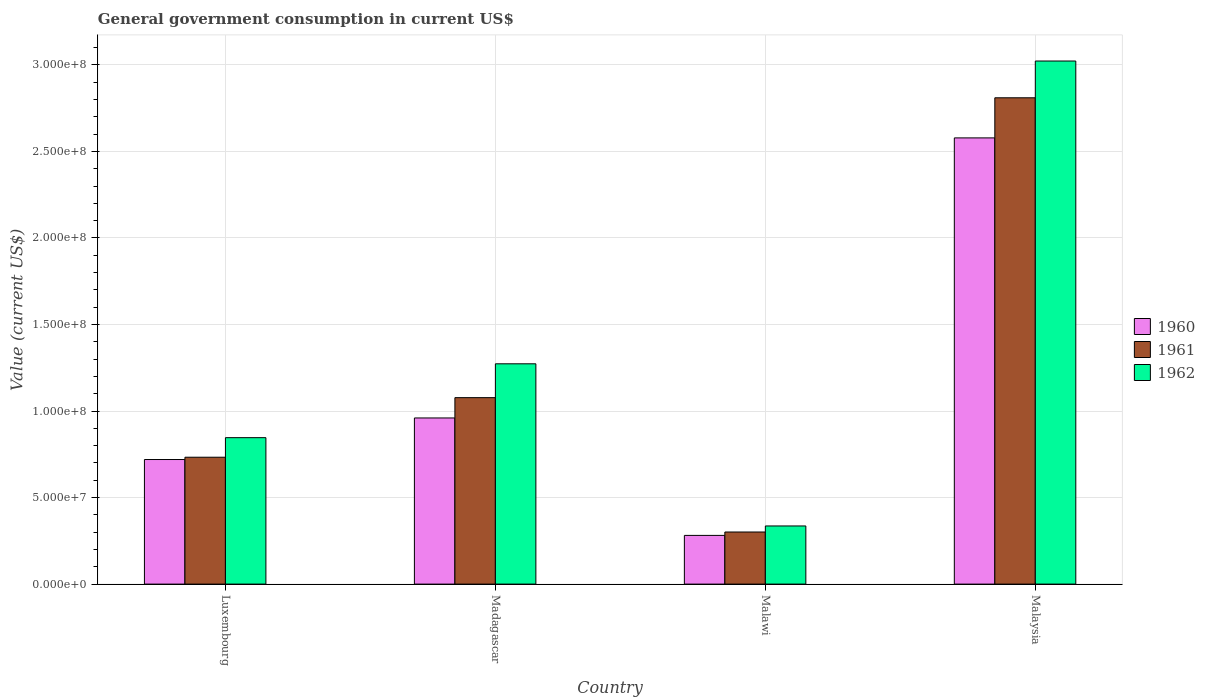Are the number of bars per tick equal to the number of legend labels?
Offer a very short reply. Yes. How many bars are there on the 3rd tick from the left?
Ensure brevity in your answer.  3. What is the label of the 4th group of bars from the left?
Your response must be concise. Malaysia. What is the government conusmption in 1960 in Malawi?
Make the answer very short. 2.81e+07. Across all countries, what is the maximum government conusmption in 1962?
Your response must be concise. 3.02e+08. Across all countries, what is the minimum government conusmption in 1960?
Provide a short and direct response. 2.81e+07. In which country was the government conusmption in 1962 maximum?
Your answer should be very brief. Malaysia. In which country was the government conusmption in 1962 minimum?
Provide a short and direct response. Malawi. What is the total government conusmption in 1962 in the graph?
Keep it short and to the point. 5.48e+08. What is the difference between the government conusmption in 1961 in Madagascar and that in Malawi?
Offer a very short reply. 7.76e+07. What is the difference between the government conusmption in 1960 in Malawi and the government conusmption in 1962 in Malaysia?
Offer a very short reply. -2.74e+08. What is the average government conusmption in 1962 per country?
Give a very brief answer. 1.37e+08. What is the difference between the government conusmption of/in 1961 and government conusmption of/in 1960 in Malaysia?
Keep it short and to the point. 2.32e+07. In how many countries, is the government conusmption in 1961 greater than 300000000 US$?
Offer a very short reply. 0. What is the ratio of the government conusmption in 1962 in Madagascar to that in Malaysia?
Provide a succinct answer. 0.42. Is the government conusmption in 1961 in Luxembourg less than that in Malawi?
Your response must be concise. No. Is the difference between the government conusmption in 1961 in Madagascar and Malaysia greater than the difference between the government conusmption in 1960 in Madagascar and Malaysia?
Give a very brief answer. No. What is the difference between the highest and the second highest government conusmption in 1962?
Provide a succinct answer. -4.27e+07. What is the difference between the highest and the lowest government conusmption in 1962?
Provide a succinct answer. 2.69e+08. Is the sum of the government conusmption in 1962 in Malawi and Malaysia greater than the maximum government conusmption in 1961 across all countries?
Provide a succinct answer. Yes. What does the 2nd bar from the right in Malawi represents?
Give a very brief answer. 1961. Are all the bars in the graph horizontal?
Your answer should be compact. No. What is the difference between two consecutive major ticks on the Y-axis?
Your response must be concise. 5.00e+07. Does the graph contain any zero values?
Your answer should be very brief. No. Does the graph contain grids?
Offer a very short reply. Yes. How many legend labels are there?
Offer a very short reply. 3. What is the title of the graph?
Ensure brevity in your answer.  General government consumption in current US$. What is the label or title of the X-axis?
Make the answer very short. Country. What is the label or title of the Y-axis?
Provide a short and direct response. Value (current US$). What is the Value (current US$) of 1960 in Luxembourg?
Provide a short and direct response. 7.20e+07. What is the Value (current US$) in 1961 in Luxembourg?
Give a very brief answer. 7.33e+07. What is the Value (current US$) in 1962 in Luxembourg?
Offer a very short reply. 8.46e+07. What is the Value (current US$) of 1960 in Madagascar?
Offer a very short reply. 9.60e+07. What is the Value (current US$) of 1961 in Madagascar?
Your answer should be compact. 1.08e+08. What is the Value (current US$) in 1962 in Madagascar?
Give a very brief answer. 1.27e+08. What is the Value (current US$) of 1960 in Malawi?
Your answer should be very brief. 2.81e+07. What is the Value (current US$) in 1961 in Malawi?
Provide a succinct answer. 3.01e+07. What is the Value (current US$) of 1962 in Malawi?
Your answer should be compact. 3.36e+07. What is the Value (current US$) of 1960 in Malaysia?
Provide a succinct answer. 2.58e+08. What is the Value (current US$) of 1961 in Malaysia?
Give a very brief answer. 2.81e+08. What is the Value (current US$) in 1962 in Malaysia?
Give a very brief answer. 3.02e+08. Across all countries, what is the maximum Value (current US$) in 1960?
Your answer should be compact. 2.58e+08. Across all countries, what is the maximum Value (current US$) in 1961?
Your answer should be compact. 2.81e+08. Across all countries, what is the maximum Value (current US$) of 1962?
Your answer should be compact. 3.02e+08. Across all countries, what is the minimum Value (current US$) in 1960?
Your response must be concise. 2.81e+07. Across all countries, what is the minimum Value (current US$) in 1961?
Ensure brevity in your answer.  3.01e+07. Across all countries, what is the minimum Value (current US$) in 1962?
Keep it short and to the point. 3.36e+07. What is the total Value (current US$) in 1960 in the graph?
Offer a terse response. 4.54e+08. What is the total Value (current US$) of 1961 in the graph?
Your answer should be compact. 4.92e+08. What is the total Value (current US$) of 1962 in the graph?
Provide a succinct answer. 5.48e+08. What is the difference between the Value (current US$) of 1960 in Luxembourg and that in Madagascar?
Your answer should be very brief. -2.40e+07. What is the difference between the Value (current US$) of 1961 in Luxembourg and that in Madagascar?
Give a very brief answer. -3.44e+07. What is the difference between the Value (current US$) of 1962 in Luxembourg and that in Madagascar?
Offer a terse response. -4.27e+07. What is the difference between the Value (current US$) in 1960 in Luxembourg and that in Malawi?
Offer a terse response. 4.38e+07. What is the difference between the Value (current US$) of 1961 in Luxembourg and that in Malawi?
Your answer should be compact. 4.32e+07. What is the difference between the Value (current US$) of 1962 in Luxembourg and that in Malawi?
Make the answer very short. 5.10e+07. What is the difference between the Value (current US$) in 1960 in Luxembourg and that in Malaysia?
Your answer should be compact. -1.86e+08. What is the difference between the Value (current US$) in 1961 in Luxembourg and that in Malaysia?
Give a very brief answer. -2.08e+08. What is the difference between the Value (current US$) of 1962 in Luxembourg and that in Malaysia?
Offer a terse response. -2.18e+08. What is the difference between the Value (current US$) of 1960 in Madagascar and that in Malawi?
Provide a short and direct response. 6.79e+07. What is the difference between the Value (current US$) of 1961 in Madagascar and that in Malawi?
Keep it short and to the point. 7.76e+07. What is the difference between the Value (current US$) in 1962 in Madagascar and that in Malawi?
Your answer should be very brief. 9.37e+07. What is the difference between the Value (current US$) in 1960 in Madagascar and that in Malaysia?
Your answer should be compact. -1.62e+08. What is the difference between the Value (current US$) in 1961 in Madagascar and that in Malaysia?
Keep it short and to the point. -1.73e+08. What is the difference between the Value (current US$) in 1962 in Madagascar and that in Malaysia?
Provide a succinct answer. -1.75e+08. What is the difference between the Value (current US$) in 1960 in Malawi and that in Malaysia?
Provide a succinct answer. -2.30e+08. What is the difference between the Value (current US$) in 1961 in Malawi and that in Malaysia?
Provide a short and direct response. -2.51e+08. What is the difference between the Value (current US$) of 1962 in Malawi and that in Malaysia?
Your answer should be compact. -2.69e+08. What is the difference between the Value (current US$) in 1960 in Luxembourg and the Value (current US$) in 1961 in Madagascar?
Keep it short and to the point. -3.58e+07. What is the difference between the Value (current US$) in 1960 in Luxembourg and the Value (current US$) in 1962 in Madagascar?
Offer a terse response. -5.53e+07. What is the difference between the Value (current US$) of 1961 in Luxembourg and the Value (current US$) of 1962 in Madagascar?
Your response must be concise. -5.40e+07. What is the difference between the Value (current US$) in 1960 in Luxembourg and the Value (current US$) in 1961 in Malawi?
Offer a terse response. 4.19e+07. What is the difference between the Value (current US$) in 1960 in Luxembourg and the Value (current US$) in 1962 in Malawi?
Offer a very short reply. 3.84e+07. What is the difference between the Value (current US$) of 1961 in Luxembourg and the Value (current US$) of 1962 in Malawi?
Offer a very short reply. 3.97e+07. What is the difference between the Value (current US$) of 1960 in Luxembourg and the Value (current US$) of 1961 in Malaysia?
Your response must be concise. -2.09e+08. What is the difference between the Value (current US$) in 1960 in Luxembourg and the Value (current US$) in 1962 in Malaysia?
Provide a succinct answer. -2.30e+08. What is the difference between the Value (current US$) of 1961 in Luxembourg and the Value (current US$) of 1962 in Malaysia?
Provide a short and direct response. -2.29e+08. What is the difference between the Value (current US$) of 1960 in Madagascar and the Value (current US$) of 1961 in Malawi?
Make the answer very short. 6.59e+07. What is the difference between the Value (current US$) in 1960 in Madagascar and the Value (current US$) in 1962 in Malawi?
Provide a succinct answer. 6.24e+07. What is the difference between the Value (current US$) of 1961 in Madagascar and the Value (current US$) of 1962 in Malawi?
Provide a succinct answer. 7.41e+07. What is the difference between the Value (current US$) of 1960 in Madagascar and the Value (current US$) of 1961 in Malaysia?
Offer a terse response. -1.85e+08. What is the difference between the Value (current US$) of 1960 in Madagascar and the Value (current US$) of 1962 in Malaysia?
Ensure brevity in your answer.  -2.06e+08. What is the difference between the Value (current US$) of 1961 in Madagascar and the Value (current US$) of 1962 in Malaysia?
Give a very brief answer. -1.95e+08. What is the difference between the Value (current US$) in 1960 in Malawi and the Value (current US$) in 1961 in Malaysia?
Make the answer very short. -2.53e+08. What is the difference between the Value (current US$) of 1960 in Malawi and the Value (current US$) of 1962 in Malaysia?
Keep it short and to the point. -2.74e+08. What is the difference between the Value (current US$) in 1961 in Malawi and the Value (current US$) in 1962 in Malaysia?
Your response must be concise. -2.72e+08. What is the average Value (current US$) in 1960 per country?
Make the answer very short. 1.13e+08. What is the average Value (current US$) of 1961 per country?
Your answer should be compact. 1.23e+08. What is the average Value (current US$) of 1962 per country?
Provide a short and direct response. 1.37e+08. What is the difference between the Value (current US$) in 1960 and Value (current US$) in 1961 in Luxembourg?
Offer a terse response. -1.33e+06. What is the difference between the Value (current US$) in 1960 and Value (current US$) in 1962 in Luxembourg?
Keep it short and to the point. -1.26e+07. What is the difference between the Value (current US$) of 1961 and Value (current US$) of 1962 in Luxembourg?
Your response must be concise. -1.13e+07. What is the difference between the Value (current US$) in 1960 and Value (current US$) in 1961 in Madagascar?
Ensure brevity in your answer.  -1.17e+07. What is the difference between the Value (current US$) in 1960 and Value (current US$) in 1962 in Madagascar?
Offer a terse response. -3.13e+07. What is the difference between the Value (current US$) of 1961 and Value (current US$) of 1962 in Madagascar?
Your answer should be compact. -1.96e+07. What is the difference between the Value (current US$) of 1960 and Value (current US$) of 1961 in Malawi?
Offer a very short reply. -1.96e+06. What is the difference between the Value (current US$) of 1960 and Value (current US$) of 1962 in Malawi?
Offer a terse response. -5.46e+06. What is the difference between the Value (current US$) in 1961 and Value (current US$) in 1962 in Malawi?
Give a very brief answer. -3.50e+06. What is the difference between the Value (current US$) of 1960 and Value (current US$) of 1961 in Malaysia?
Your response must be concise. -2.32e+07. What is the difference between the Value (current US$) in 1960 and Value (current US$) in 1962 in Malaysia?
Provide a short and direct response. -4.44e+07. What is the difference between the Value (current US$) in 1961 and Value (current US$) in 1962 in Malaysia?
Your response must be concise. -2.12e+07. What is the ratio of the Value (current US$) of 1960 in Luxembourg to that in Madagascar?
Give a very brief answer. 0.75. What is the ratio of the Value (current US$) of 1961 in Luxembourg to that in Madagascar?
Offer a very short reply. 0.68. What is the ratio of the Value (current US$) in 1962 in Luxembourg to that in Madagascar?
Offer a terse response. 0.66. What is the ratio of the Value (current US$) in 1960 in Luxembourg to that in Malawi?
Your answer should be compact. 2.56. What is the ratio of the Value (current US$) in 1961 in Luxembourg to that in Malawi?
Offer a very short reply. 2.44. What is the ratio of the Value (current US$) of 1962 in Luxembourg to that in Malawi?
Provide a succinct answer. 2.52. What is the ratio of the Value (current US$) of 1960 in Luxembourg to that in Malaysia?
Provide a short and direct response. 0.28. What is the ratio of the Value (current US$) of 1961 in Luxembourg to that in Malaysia?
Your answer should be compact. 0.26. What is the ratio of the Value (current US$) in 1962 in Luxembourg to that in Malaysia?
Your response must be concise. 0.28. What is the ratio of the Value (current US$) in 1960 in Madagascar to that in Malawi?
Provide a short and direct response. 3.41. What is the ratio of the Value (current US$) in 1961 in Madagascar to that in Malawi?
Give a very brief answer. 3.58. What is the ratio of the Value (current US$) of 1962 in Madagascar to that in Malawi?
Offer a terse response. 3.79. What is the ratio of the Value (current US$) of 1960 in Madagascar to that in Malaysia?
Your answer should be compact. 0.37. What is the ratio of the Value (current US$) of 1961 in Madagascar to that in Malaysia?
Provide a short and direct response. 0.38. What is the ratio of the Value (current US$) in 1962 in Madagascar to that in Malaysia?
Your response must be concise. 0.42. What is the ratio of the Value (current US$) of 1960 in Malawi to that in Malaysia?
Your answer should be very brief. 0.11. What is the ratio of the Value (current US$) of 1961 in Malawi to that in Malaysia?
Your answer should be very brief. 0.11. What is the ratio of the Value (current US$) of 1962 in Malawi to that in Malaysia?
Make the answer very short. 0.11. What is the difference between the highest and the second highest Value (current US$) of 1960?
Keep it short and to the point. 1.62e+08. What is the difference between the highest and the second highest Value (current US$) in 1961?
Your answer should be very brief. 1.73e+08. What is the difference between the highest and the second highest Value (current US$) of 1962?
Offer a terse response. 1.75e+08. What is the difference between the highest and the lowest Value (current US$) in 1960?
Provide a succinct answer. 2.30e+08. What is the difference between the highest and the lowest Value (current US$) of 1961?
Give a very brief answer. 2.51e+08. What is the difference between the highest and the lowest Value (current US$) in 1962?
Provide a short and direct response. 2.69e+08. 